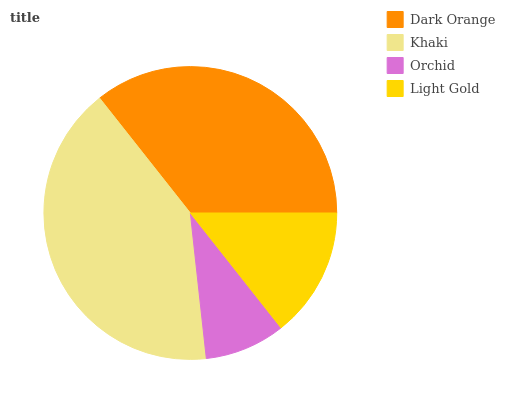Is Orchid the minimum?
Answer yes or no. Yes. Is Khaki the maximum?
Answer yes or no. Yes. Is Khaki the minimum?
Answer yes or no. No. Is Orchid the maximum?
Answer yes or no. No. Is Khaki greater than Orchid?
Answer yes or no. Yes. Is Orchid less than Khaki?
Answer yes or no. Yes. Is Orchid greater than Khaki?
Answer yes or no. No. Is Khaki less than Orchid?
Answer yes or no. No. Is Dark Orange the high median?
Answer yes or no. Yes. Is Light Gold the low median?
Answer yes or no. Yes. Is Light Gold the high median?
Answer yes or no. No. Is Dark Orange the low median?
Answer yes or no. No. 